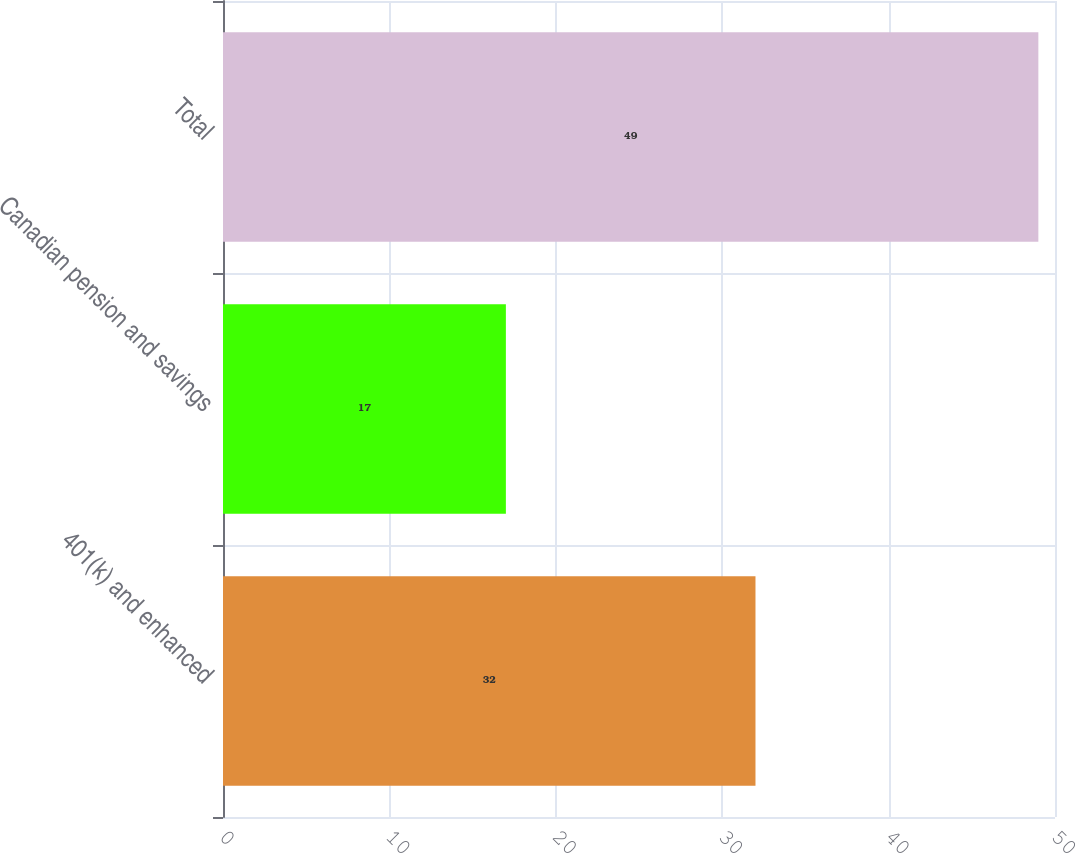Convert chart to OTSL. <chart><loc_0><loc_0><loc_500><loc_500><bar_chart><fcel>401(k) and enhanced<fcel>Canadian pension and savings<fcel>Total<nl><fcel>32<fcel>17<fcel>49<nl></chart> 